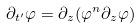Convert formula to latex. <formula><loc_0><loc_0><loc_500><loc_500>\partial _ { t ^ { \prime } } \varphi = \partial _ { z } ( \varphi ^ { n } \partial _ { z } \varphi )</formula> 